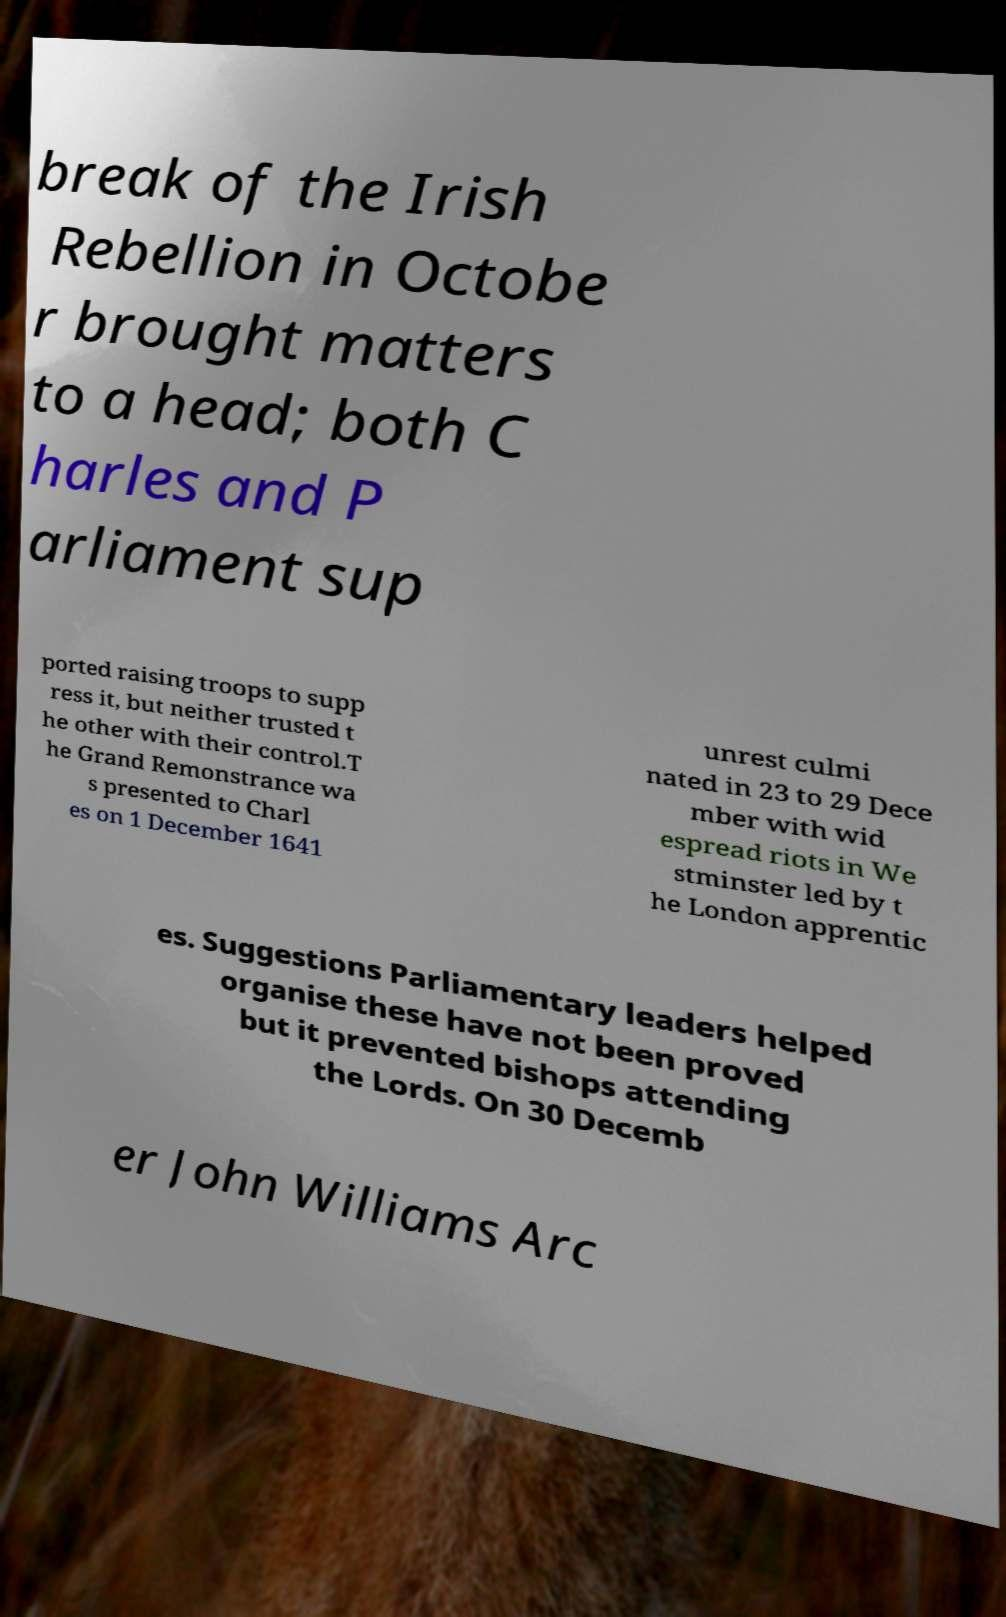Please identify and transcribe the text found in this image. break of the Irish Rebellion in Octobe r brought matters to a head; both C harles and P arliament sup ported raising troops to supp ress it, but neither trusted t he other with their control.T he Grand Remonstrance wa s presented to Charl es on 1 December 1641 unrest culmi nated in 23 to 29 Dece mber with wid espread riots in We stminster led by t he London apprentic es. Suggestions Parliamentary leaders helped organise these have not been proved but it prevented bishops attending the Lords. On 30 Decemb er John Williams Arc 